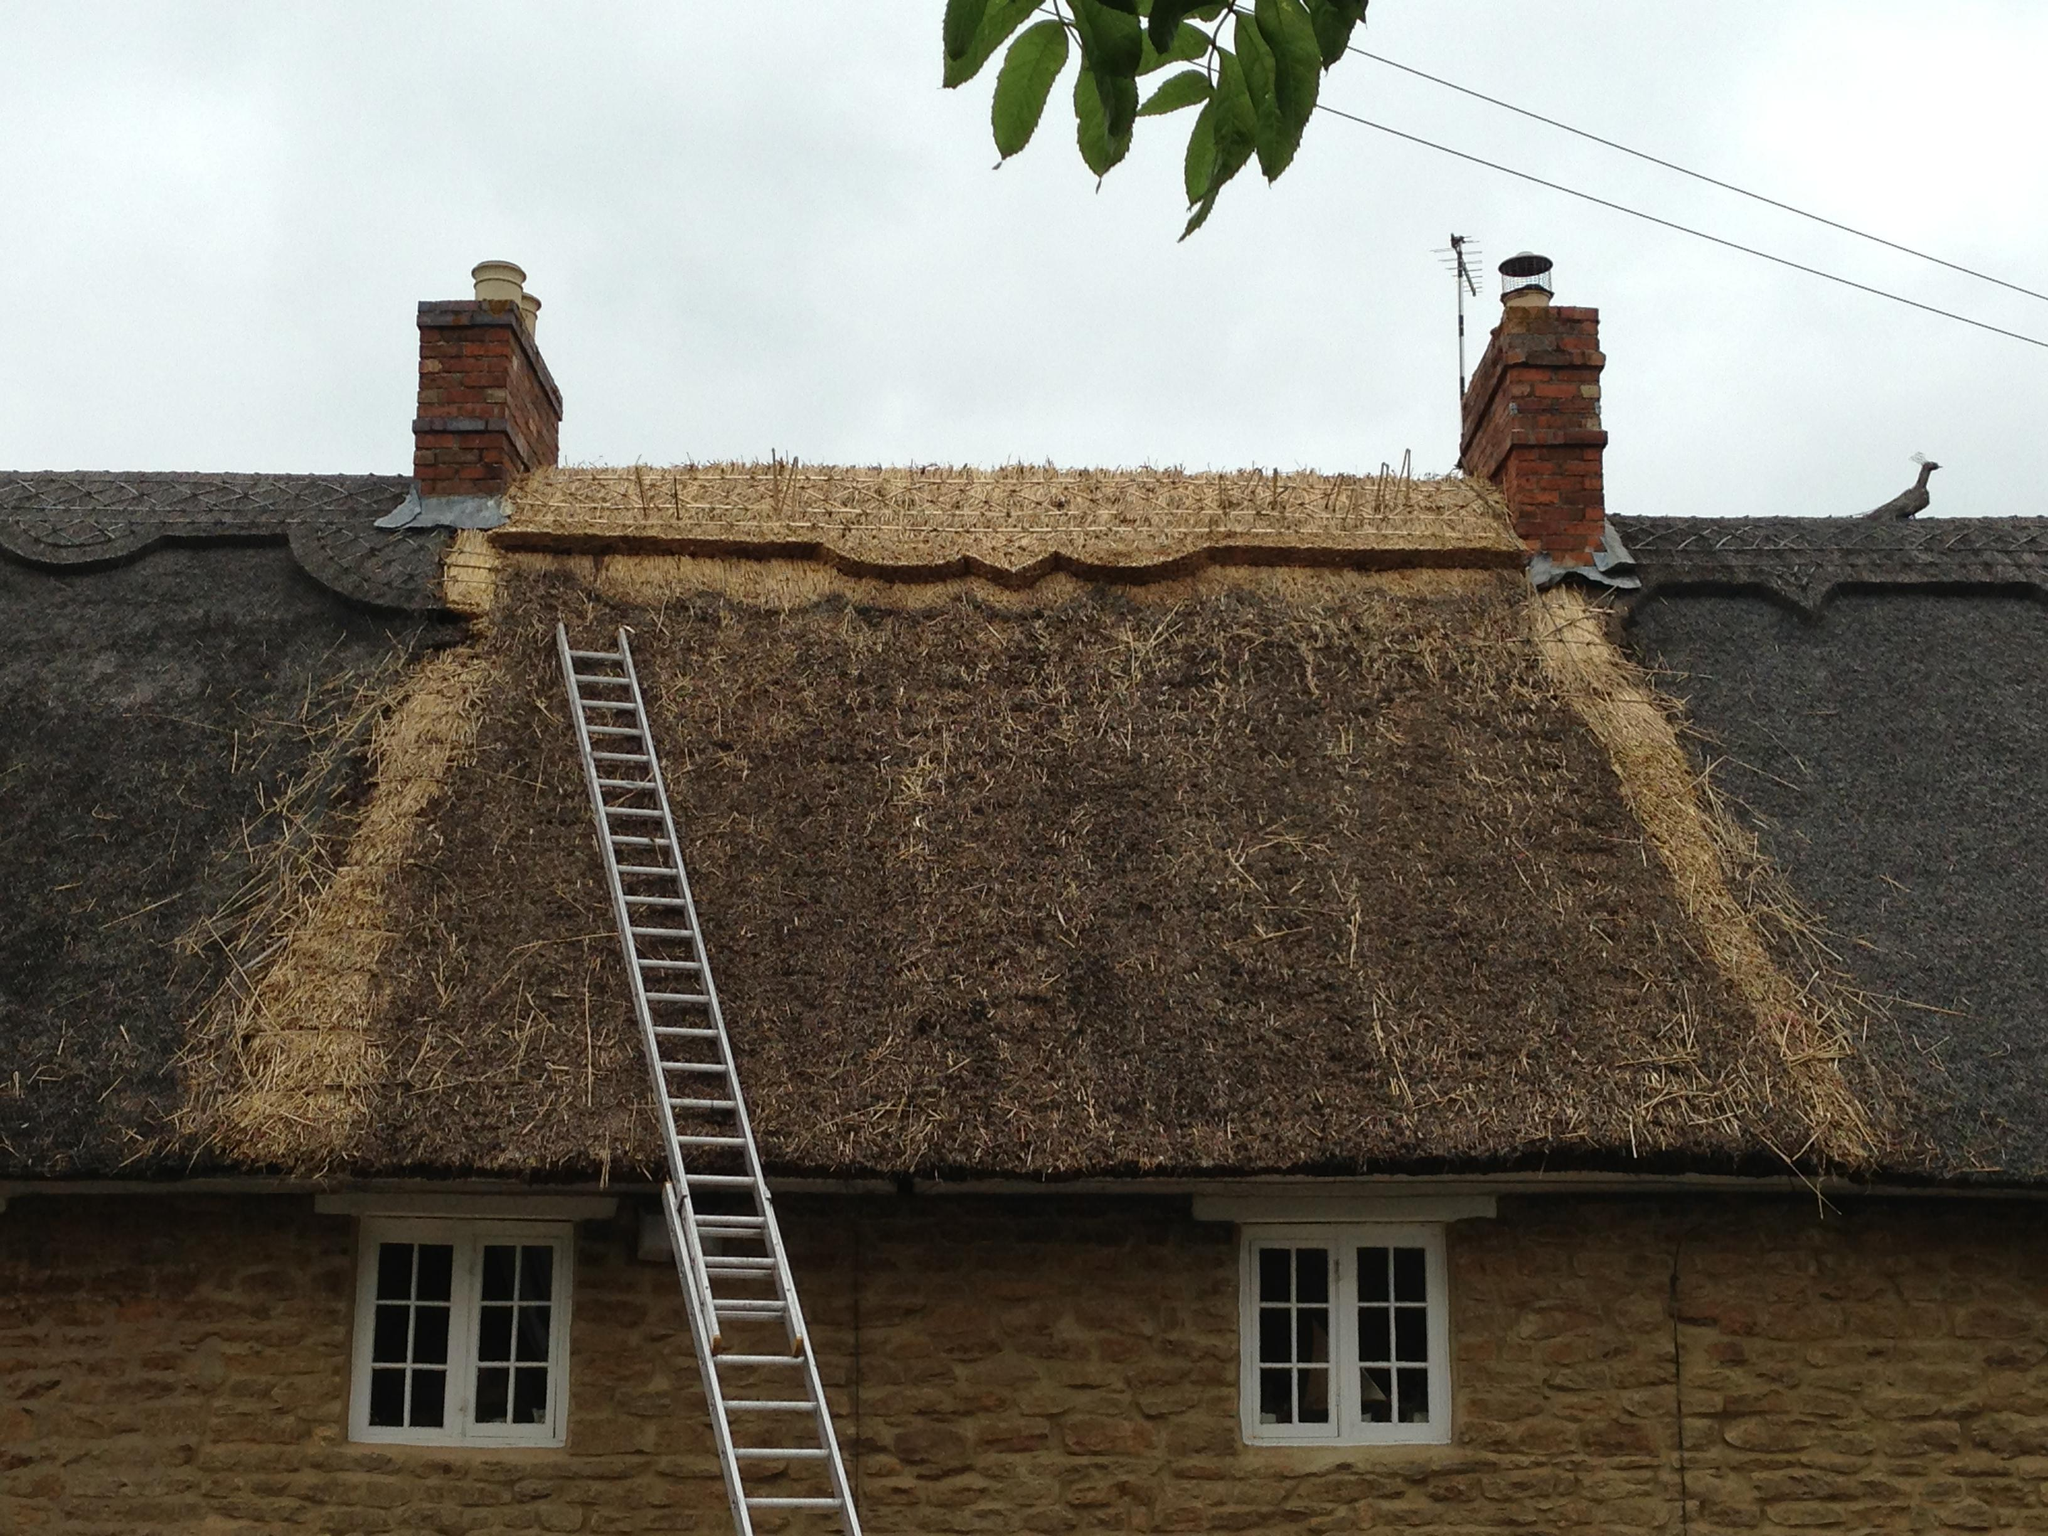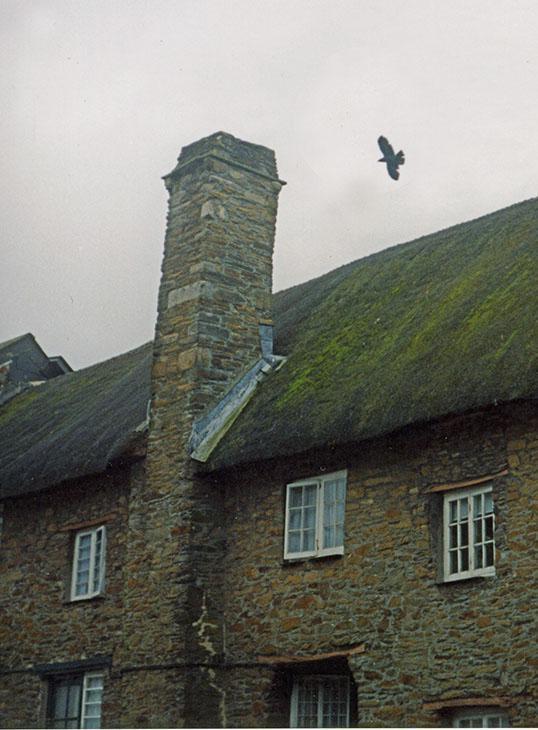The first image is the image on the left, the second image is the image on the right. Given the left and right images, does the statement "In at least one image there is a silver ladder placed on the roof pointed toward the brick chimney." hold true? Answer yes or no. Yes. The first image is the image on the left, the second image is the image on the right. Evaluate the accuracy of this statement regarding the images: "The left image shows a ladder leaning against a thatched roof, with the top of the ladder near a red brick chimney.". Is it true? Answer yes or no. Yes. 